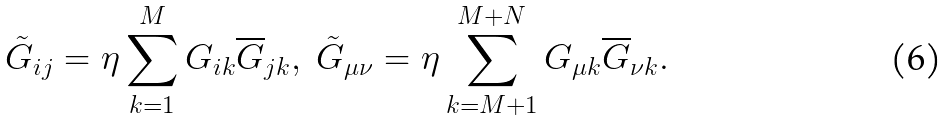Convert formula to latex. <formula><loc_0><loc_0><loc_500><loc_500>\tilde { G } _ { i j } = \eta \sum _ { k = 1 } ^ { M } G _ { i k } \overline { G } _ { j k } , \ \tilde { G } _ { \mu \nu } = \eta \sum _ { k = M + 1 } ^ { M + N } G _ { \mu k } \overline { G } _ { \nu k } .</formula> 